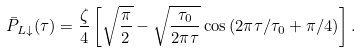Convert formula to latex. <formula><loc_0><loc_0><loc_500><loc_500>\bar { P } _ { L \downarrow } ( \tau ) = \frac { \zeta } { 4 } \left [ \sqrt { \frac { \pi } { 2 } } - \sqrt { \frac { \tau _ { 0 } } { 2 \pi \tau } } \cos \left ( 2 \pi \tau / \tau _ { 0 } + \pi / 4 \right ) \right ] .</formula> 